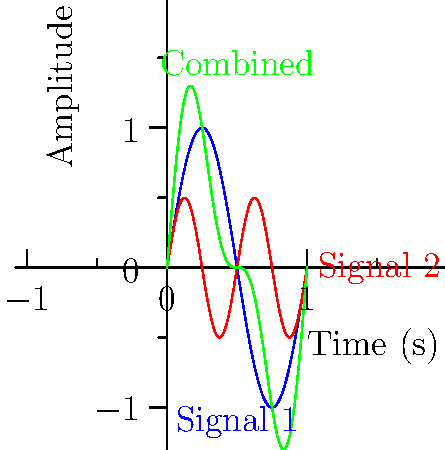As the police chief overseeing drone operations, you receive the waveform diagram shown above from a surveillance drone. The green line represents the combined encrypted video signal. Given that Signal 1 (blue) is the carrier wave and Signal 2 (red) is the data signal, what modulation technique is being used to encrypt the video transmission? To determine the modulation technique, we need to analyze the characteristics of the signals:

1. Signal 1 (blue) is a sinusoidal wave with a higher frequency and amplitude. This is typical of a carrier wave.

2. Signal 2 (red) is also sinusoidal but with lower frequency and amplitude. This represents the data signal.

3. The combined signal (green) shows characteristics of both input signals.

4. The amplitude of the combined signal varies according to the data signal, while its frequency remains constant (matching the carrier wave).

5. This behavior is characteristic of Amplitude Modulation (AM), where the amplitude of the carrier wave is varied in proportion to the data signal.

6. In AM, the equation for the modulated signal is:
   $$s(t) = A_c[1 + m(t)]cos(2\pi f_c t)$$
   where $A_c$ is the carrier amplitude, $m(t)$ is the modulating signal, and $f_c$ is the carrier frequency.

7. The green line in the diagram closely matches this behavior, showing amplitude variations while maintaining the carrier frequency.

Therefore, the modulation technique used for encrypting the video transmission is Amplitude Modulation (AM).
Answer: Amplitude Modulation (AM) 